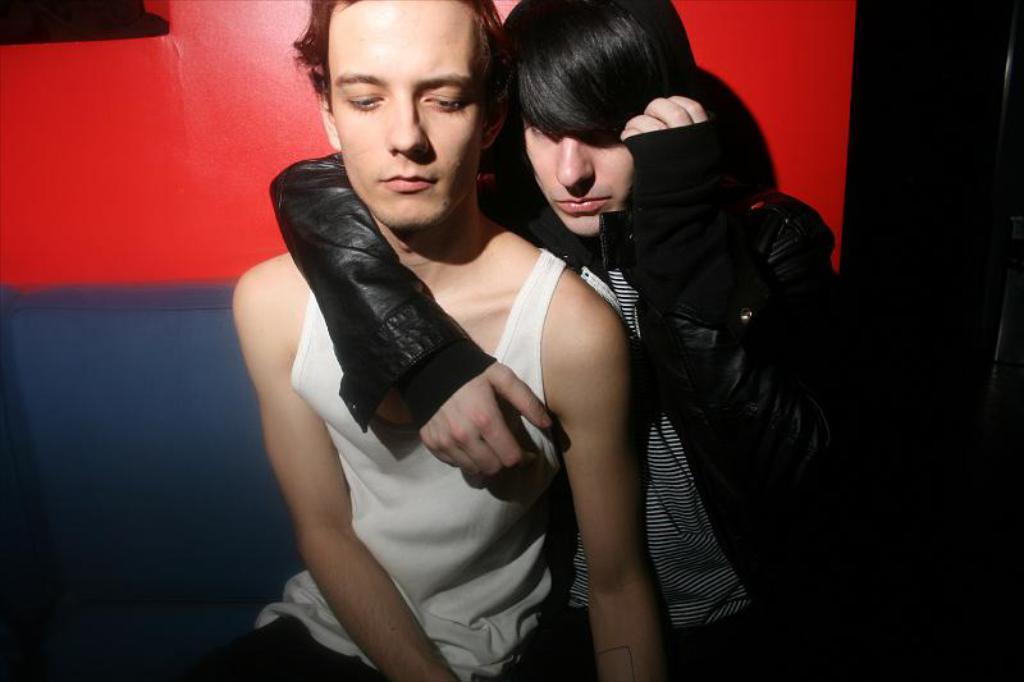Describe this image in one or two sentences. In this image there are two people sitting on the sofa, there's a wall. 